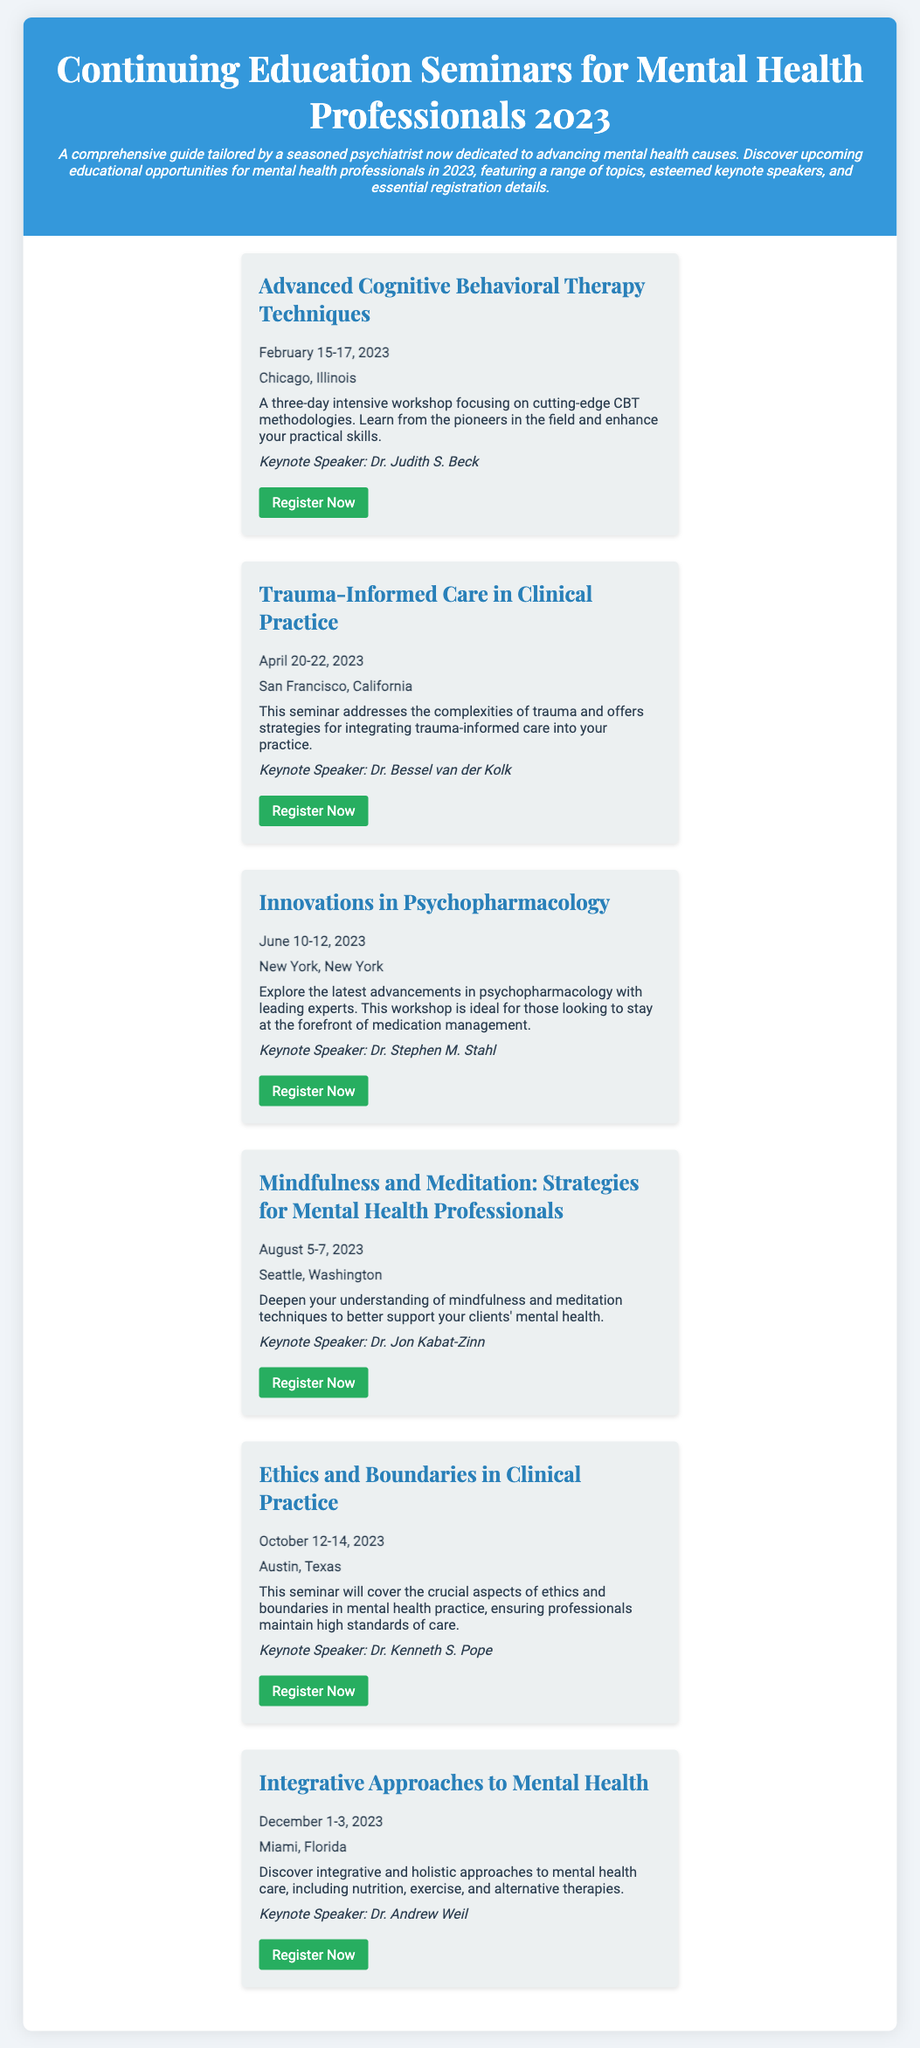What is the title of the first seminar? The title of the first seminar is stated in the document as the first event listed under the seminars section.
Answer: Advanced Cognitive Behavioral Therapy Techniques Who is the keynote speaker for the seminar on Trauma-Informed Care? The keynote speaker for each seminar is provided in the description of that seminar.
Answer: Dr. Bessel van der Kolk What is the date range for the Ethics and Boundaries in Clinical Practice seminar? The date range is specified alongside the seminar title in the document.
Answer: October 12-14, 2023 How many days does the Innovations in Psychopharmacology workshop last? The duration of the workshop is indicated by the start and end dates provided in the seminar details.
Answer: 3 days Which city will host the seminar on Mindfulness and Meditation? The host city is listed within the details of each seminar in the document.
Answer: Seattle, Washington What topic will be covered in the seminar taking place in December? The topic is expressed in the title and description of the seminar.
Answer: Integrative Approaches to Mental Health What is the registration link for the Advanced Cognitive Behavioral Therapy Techniques seminar? The registration link is provided as a clickable text in each seminar's details.
Answer: https://www.cbtseminarschicago2023.com What is the focus of the seminar scheduled for August? The focus is mentioned in the seminar's brief description.
Answer: Mindfulness and Meditation Strategies 